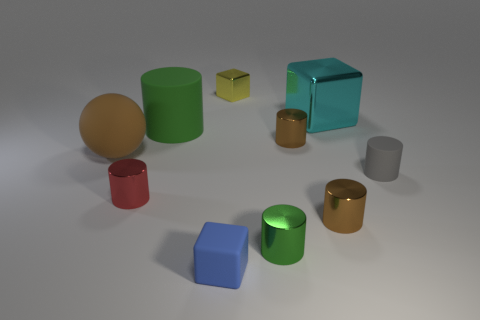Are any matte objects visible?
Your response must be concise. Yes. What is the size of the object that is both behind the tiny gray rubber cylinder and left of the big green rubber thing?
Give a very brief answer. Large. What is the shape of the big brown rubber thing?
Your response must be concise. Sphere. Is there a cyan metallic thing behind the small cube that is behind the cyan thing?
Ensure brevity in your answer.  No. There is a gray cylinder that is the same size as the red cylinder; what is it made of?
Keep it short and to the point. Rubber. Is there a brown rubber object that has the same size as the yellow shiny block?
Offer a terse response. No. What material is the brown object that is to the left of the big green cylinder?
Your answer should be compact. Rubber. Do the large thing in front of the big green cylinder and the small gray thing have the same material?
Give a very brief answer. Yes. What is the shape of the red object that is the same size as the gray matte thing?
Your answer should be very brief. Cylinder. What number of metallic cylinders are the same color as the large ball?
Ensure brevity in your answer.  2. 